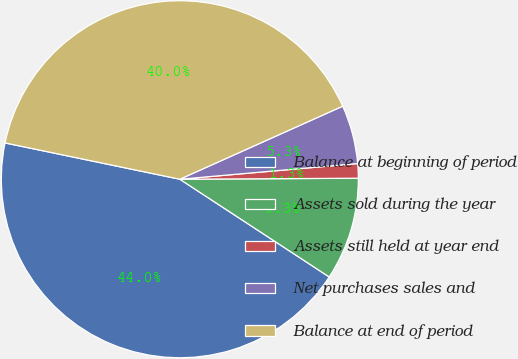<chart> <loc_0><loc_0><loc_500><loc_500><pie_chart><fcel>Balance at beginning of period<fcel>Assets sold during the year<fcel>Assets still held at year end<fcel>Net purchases sales and<fcel>Balance at end of period<nl><fcel>44.04%<fcel>9.31%<fcel>1.31%<fcel>5.31%<fcel>40.03%<nl></chart> 